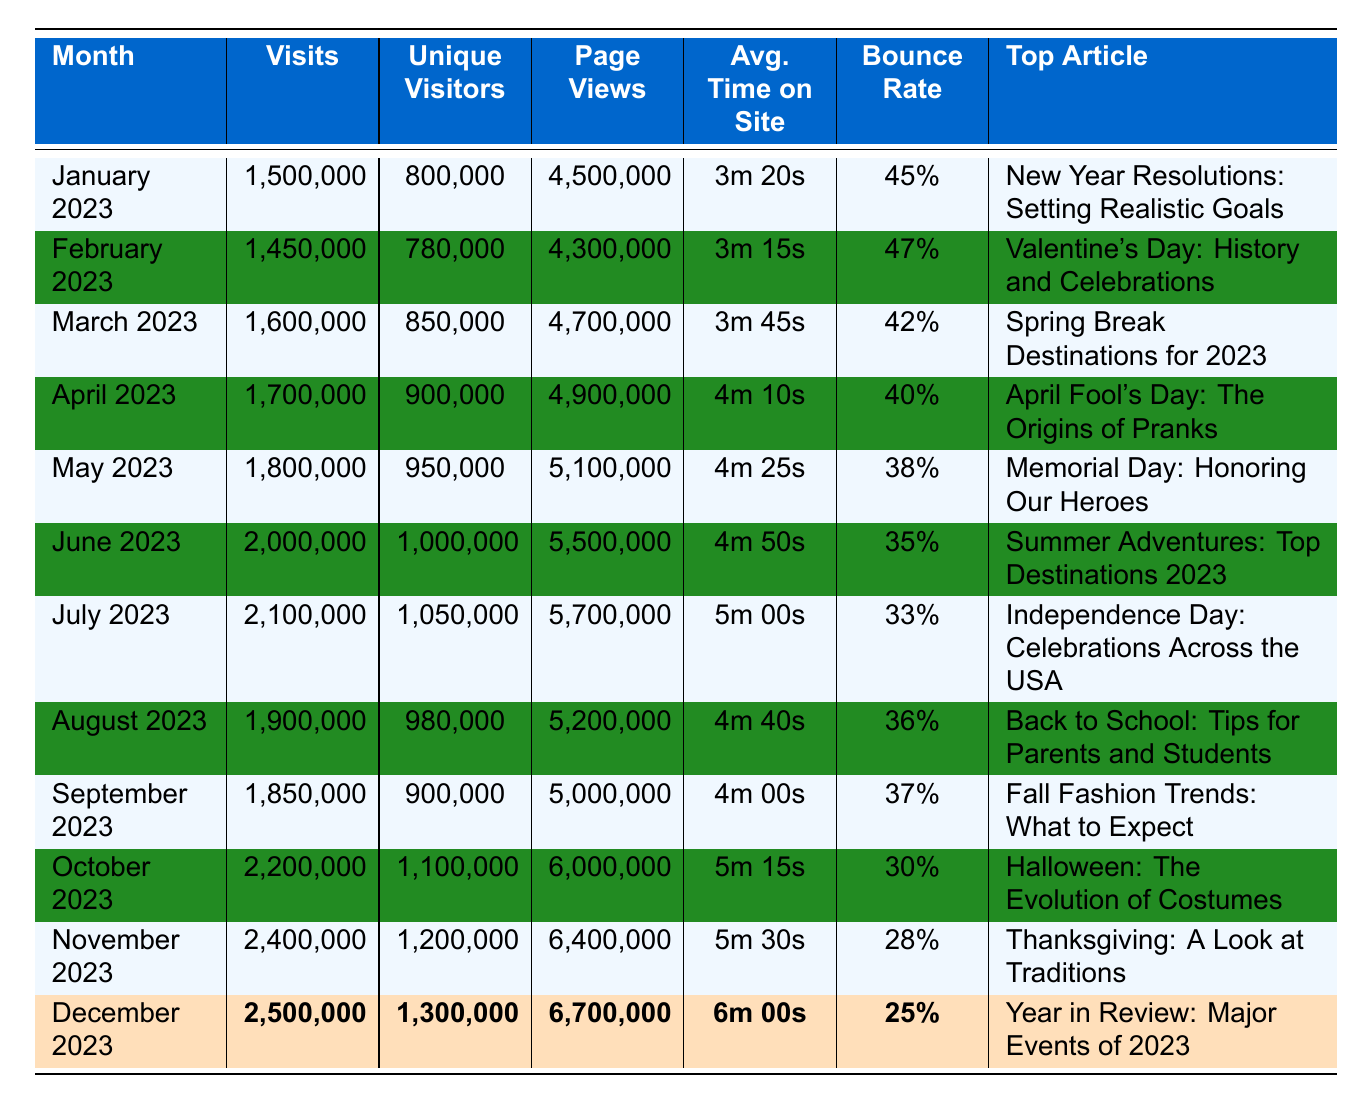What was the top article in June 2023? The table lists the top article for each month. For June 2023, it states "Summer Adventures: Top Destinations 2023" as the top article.
Answer: Summer Adventures: Top Destinations 2023 Which month had the highest unique visitors? By examining the unique visitors column, December 2023 shows 1,300,000, which is the highest number compared to the other months.
Answer: December 2023 What was the bounce rate in October 2023? Looking at the bounce rate column for October 2023, the value listed is 30%.
Answer: 30% What is the average number of visits from January to March 2023? The total visits from January (1,500,000), February (1,450,000), and March (1,600,000) equals 4,550,000. Dividing this by the number of months (3) gives an average of 1,516,667.
Answer: 1,516,667 Was there a month with a bounce rate lower than 35%? A quick check of the bounce rates reveals that October (30%) and November (28%) both have rates lower than 35%.
Answer: Yes In which month did the average time on site exceed 5 minutes? Examining the average time on site, it is noted that July (5m 00s), October (5m 15s), November (5m 30s), and December (6m 00s) all exceed 5 minutes. The first instance of this is in July.
Answer: July 2023 How much did visits increase from May to June 2023? By subtracting the visits in May (1,800,000) from June (2,000,000), we find the increase is 200,000 visits.
Answer: 200,000 Which month had the most page views? The highest number of page views can be found in December 2023 at 6,700,000.
Answer: December 2023 What is the average bounce rate for the first half of the year (January to June 2023)? The bounce rates for January (45%), February (47%), March (42%), April (40%), May (38%), and June (35%) total 247%. Dividing this by 6 months gives an average of 41.17%.
Answer: 41.17% Was there a decline in unique visitors from August to September 2023? The unique visitors for August (980,000) and September (900,000) show a decrease when comparing the two values. The difference is 80,000.
Answer: Yes 